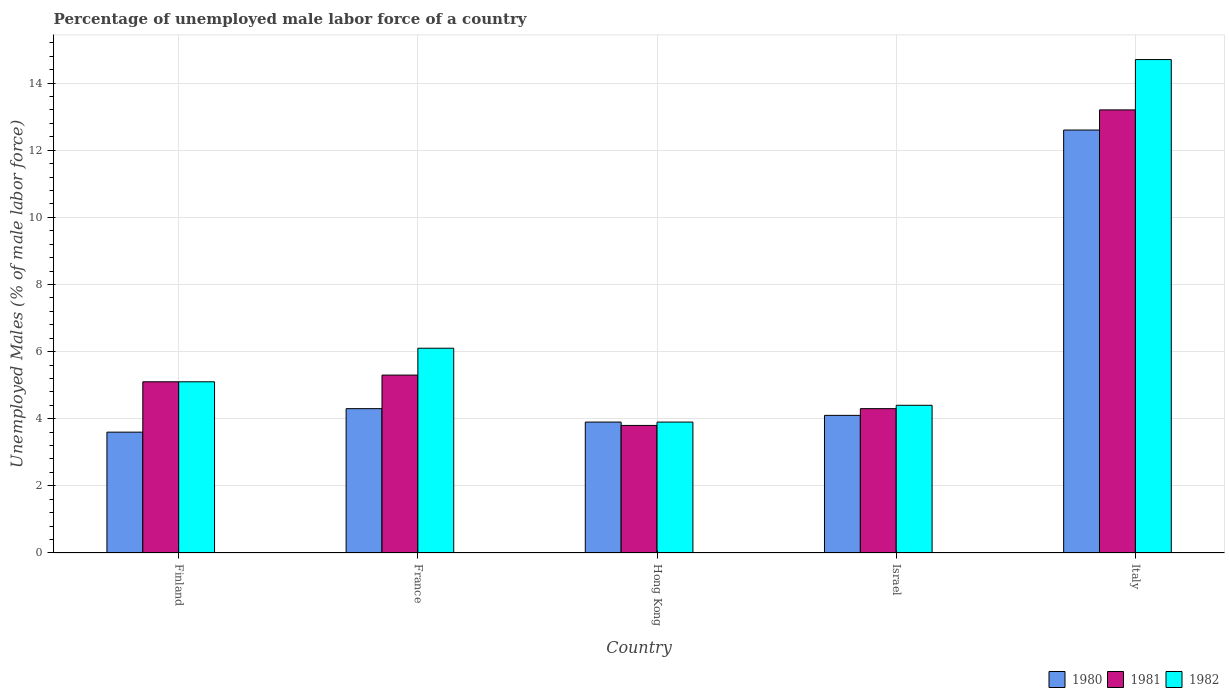How many different coloured bars are there?
Your response must be concise. 3. How many groups of bars are there?
Keep it short and to the point. 5. Are the number of bars per tick equal to the number of legend labels?
Ensure brevity in your answer.  Yes. How many bars are there on the 5th tick from the right?
Provide a succinct answer. 3. What is the percentage of unemployed male labor force in 1980 in Hong Kong?
Give a very brief answer. 3.9. Across all countries, what is the maximum percentage of unemployed male labor force in 1980?
Make the answer very short. 12.6. Across all countries, what is the minimum percentage of unemployed male labor force in 1980?
Make the answer very short. 3.6. In which country was the percentage of unemployed male labor force in 1980 maximum?
Offer a terse response. Italy. In which country was the percentage of unemployed male labor force in 1980 minimum?
Offer a very short reply. Finland. What is the total percentage of unemployed male labor force in 1980 in the graph?
Ensure brevity in your answer.  28.5. What is the difference between the percentage of unemployed male labor force in 1980 in Finland and that in France?
Provide a succinct answer. -0.7. What is the difference between the percentage of unemployed male labor force in 1982 in France and the percentage of unemployed male labor force in 1980 in Israel?
Keep it short and to the point. 2. What is the average percentage of unemployed male labor force in 1981 per country?
Give a very brief answer. 6.34. What is the difference between the percentage of unemployed male labor force of/in 1981 and percentage of unemployed male labor force of/in 1980 in Italy?
Offer a very short reply. 0.6. What is the ratio of the percentage of unemployed male labor force in 1982 in Finland to that in Italy?
Provide a short and direct response. 0.35. What is the difference between the highest and the second highest percentage of unemployed male labor force in 1982?
Your answer should be very brief. -9.6. What is the difference between the highest and the lowest percentage of unemployed male labor force in 1981?
Your answer should be very brief. 9.4. In how many countries, is the percentage of unemployed male labor force in 1982 greater than the average percentage of unemployed male labor force in 1982 taken over all countries?
Offer a very short reply. 1. Is the sum of the percentage of unemployed male labor force in 1981 in Finland and Israel greater than the maximum percentage of unemployed male labor force in 1980 across all countries?
Your answer should be compact. No. What does the 1st bar from the left in Finland represents?
Your answer should be compact. 1980. What does the 1st bar from the right in France represents?
Offer a very short reply. 1982. Are all the bars in the graph horizontal?
Offer a terse response. No. How many countries are there in the graph?
Give a very brief answer. 5. What is the difference between two consecutive major ticks on the Y-axis?
Make the answer very short. 2. Are the values on the major ticks of Y-axis written in scientific E-notation?
Offer a very short reply. No. Where does the legend appear in the graph?
Your answer should be very brief. Bottom right. How are the legend labels stacked?
Keep it short and to the point. Horizontal. What is the title of the graph?
Offer a very short reply. Percentage of unemployed male labor force of a country. What is the label or title of the Y-axis?
Provide a short and direct response. Unemployed Males (% of male labor force). What is the Unemployed Males (% of male labor force) of 1980 in Finland?
Offer a very short reply. 3.6. What is the Unemployed Males (% of male labor force) in 1981 in Finland?
Your answer should be very brief. 5.1. What is the Unemployed Males (% of male labor force) of 1982 in Finland?
Keep it short and to the point. 5.1. What is the Unemployed Males (% of male labor force) in 1980 in France?
Give a very brief answer. 4.3. What is the Unemployed Males (% of male labor force) of 1981 in France?
Offer a terse response. 5.3. What is the Unemployed Males (% of male labor force) in 1982 in France?
Provide a succinct answer. 6.1. What is the Unemployed Males (% of male labor force) in 1980 in Hong Kong?
Make the answer very short. 3.9. What is the Unemployed Males (% of male labor force) of 1981 in Hong Kong?
Keep it short and to the point. 3.8. What is the Unemployed Males (% of male labor force) in 1982 in Hong Kong?
Ensure brevity in your answer.  3.9. What is the Unemployed Males (% of male labor force) of 1980 in Israel?
Your response must be concise. 4.1. What is the Unemployed Males (% of male labor force) in 1981 in Israel?
Your answer should be very brief. 4.3. What is the Unemployed Males (% of male labor force) in 1982 in Israel?
Your answer should be very brief. 4.4. What is the Unemployed Males (% of male labor force) in 1980 in Italy?
Offer a very short reply. 12.6. What is the Unemployed Males (% of male labor force) in 1981 in Italy?
Your answer should be compact. 13.2. What is the Unemployed Males (% of male labor force) of 1982 in Italy?
Ensure brevity in your answer.  14.7. Across all countries, what is the maximum Unemployed Males (% of male labor force) of 1980?
Offer a very short reply. 12.6. Across all countries, what is the maximum Unemployed Males (% of male labor force) of 1981?
Ensure brevity in your answer.  13.2. Across all countries, what is the maximum Unemployed Males (% of male labor force) of 1982?
Your answer should be very brief. 14.7. Across all countries, what is the minimum Unemployed Males (% of male labor force) of 1980?
Keep it short and to the point. 3.6. Across all countries, what is the minimum Unemployed Males (% of male labor force) of 1981?
Provide a short and direct response. 3.8. Across all countries, what is the minimum Unemployed Males (% of male labor force) of 1982?
Your answer should be compact. 3.9. What is the total Unemployed Males (% of male labor force) in 1981 in the graph?
Your answer should be very brief. 31.7. What is the total Unemployed Males (% of male labor force) in 1982 in the graph?
Offer a terse response. 34.2. What is the difference between the Unemployed Males (% of male labor force) in 1981 in Finland and that in France?
Offer a very short reply. -0.2. What is the difference between the Unemployed Males (% of male labor force) of 1980 in Finland and that in Israel?
Your answer should be compact. -0.5. What is the difference between the Unemployed Males (% of male labor force) in 1980 in Finland and that in Italy?
Your answer should be very brief. -9. What is the difference between the Unemployed Males (% of male labor force) of 1981 in Finland and that in Italy?
Your answer should be compact. -8.1. What is the difference between the Unemployed Males (% of male labor force) of 1982 in Finland and that in Italy?
Provide a succinct answer. -9.6. What is the difference between the Unemployed Males (% of male labor force) in 1982 in France and that in Hong Kong?
Your response must be concise. 2.2. What is the difference between the Unemployed Males (% of male labor force) of 1981 in France and that in Italy?
Offer a terse response. -7.9. What is the difference between the Unemployed Males (% of male labor force) in 1980 in Hong Kong and that in Israel?
Keep it short and to the point. -0.2. What is the difference between the Unemployed Males (% of male labor force) of 1981 in Hong Kong and that in Israel?
Your answer should be compact. -0.5. What is the difference between the Unemployed Males (% of male labor force) in 1980 in Hong Kong and that in Italy?
Provide a succinct answer. -8.7. What is the difference between the Unemployed Males (% of male labor force) in 1981 in Hong Kong and that in Italy?
Ensure brevity in your answer.  -9.4. What is the difference between the Unemployed Males (% of male labor force) in 1980 in Israel and that in Italy?
Your response must be concise. -8.5. What is the difference between the Unemployed Males (% of male labor force) of 1981 in Israel and that in Italy?
Ensure brevity in your answer.  -8.9. What is the difference between the Unemployed Males (% of male labor force) in 1980 in Finland and the Unemployed Males (% of male labor force) in 1981 in France?
Your response must be concise. -1.7. What is the difference between the Unemployed Males (% of male labor force) of 1980 in Finland and the Unemployed Males (% of male labor force) of 1982 in France?
Keep it short and to the point. -2.5. What is the difference between the Unemployed Males (% of male labor force) in 1980 in Finland and the Unemployed Males (% of male labor force) in 1981 in Hong Kong?
Your answer should be compact. -0.2. What is the difference between the Unemployed Males (% of male labor force) of 1980 in Finland and the Unemployed Males (% of male labor force) of 1982 in Hong Kong?
Your answer should be compact. -0.3. What is the difference between the Unemployed Males (% of male labor force) in 1980 in Finland and the Unemployed Males (% of male labor force) in 1981 in Italy?
Give a very brief answer. -9.6. What is the difference between the Unemployed Males (% of male labor force) of 1980 in Finland and the Unemployed Males (% of male labor force) of 1982 in Italy?
Your response must be concise. -11.1. What is the difference between the Unemployed Males (% of male labor force) of 1980 in France and the Unemployed Males (% of male labor force) of 1981 in Hong Kong?
Ensure brevity in your answer.  0.5. What is the difference between the Unemployed Males (% of male labor force) in 1980 in France and the Unemployed Males (% of male labor force) in 1982 in Hong Kong?
Keep it short and to the point. 0.4. What is the difference between the Unemployed Males (% of male labor force) of 1980 in France and the Unemployed Males (% of male labor force) of 1981 in Israel?
Provide a succinct answer. 0. What is the difference between the Unemployed Males (% of male labor force) in 1980 in France and the Unemployed Males (% of male labor force) in 1981 in Italy?
Make the answer very short. -8.9. What is the difference between the Unemployed Males (% of male labor force) of 1980 in France and the Unemployed Males (% of male labor force) of 1982 in Italy?
Ensure brevity in your answer.  -10.4. What is the difference between the Unemployed Males (% of male labor force) of 1981 in France and the Unemployed Males (% of male labor force) of 1982 in Italy?
Your answer should be compact. -9.4. What is the difference between the Unemployed Males (% of male labor force) in 1980 in Hong Kong and the Unemployed Males (% of male labor force) in 1981 in Israel?
Provide a short and direct response. -0.4. What is the difference between the Unemployed Males (% of male labor force) of 1980 in Hong Kong and the Unemployed Males (% of male labor force) of 1982 in Israel?
Your answer should be compact. -0.5. What is the difference between the Unemployed Males (% of male labor force) of 1980 in Hong Kong and the Unemployed Males (% of male labor force) of 1981 in Italy?
Provide a succinct answer. -9.3. What is the difference between the Unemployed Males (% of male labor force) of 1980 in Israel and the Unemployed Males (% of male labor force) of 1982 in Italy?
Give a very brief answer. -10.6. What is the difference between the Unemployed Males (% of male labor force) of 1981 in Israel and the Unemployed Males (% of male labor force) of 1982 in Italy?
Your response must be concise. -10.4. What is the average Unemployed Males (% of male labor force) of 1981 per country?
Provide a succinct answer. 6.34. What is the average Unemployed Males (% of male labor force) in 1982 per country?
Provide a succinct answer. 6.84. What is the difference between the Unemployed Males (% of male labor force) of 1980 and Unemployed Males (% of male labor force) of 1982 in Finland?
Your response must be concise. -1.5. What is the difference between the Unemployed Males (% of male labor force) in 1981 and Unemployed Males (% of male labor force) in 1982 in Finland?
Ensure brevity in your answer.  0. What is the difference between the Unemployed Males (% of male labor force) in 1980 and Unemployed Males (% of male labor force) in 1981 in France?
Provide a short and direct response. -1. What is the difference between the Unemployed Males (% of male labor force) in 1981 and Unemployed Males (% of male labor force) in 1982 in France?
Provide a succinct answer. -0.8. What is the difference between the Unemployed Males (% of male labor force) in 1980 and Unemployed Males (% of male labor force) in 1982 in Hong Kong?
Your response must be concise. 0. What is the difference between the Unemployed Males (% of male labor force) of 1981 and Unemployed Males (% of male labor force) of 1982 in Hong Kong?
Provide a short and direct response. -0.1. What is the difference between the Unemployed Males (% of male labor force) in 1981 and Unemployed Males (% of male labor force) in 1982 in Israel?
Provide a succinct answer. -0.1. What is the ratio of the Unemployed Males (% of male labor force) in 1980 in Finland to that in France?
Offer a terse response. 0.84. What is the ratio of the Unemployed Males (% of male labor force) in 1981 in Finland to that in France?
Your answer should be compact. 0.96. What is the ratio of the Unemployed Males (% of male labor force) of 1982 in Finland to that in France?
Offer a terse response. 0.84. What is the ratio of the Unemployed Males (% of male labor force) of 1981 in Finland to that in Hong Kong?
Your response must be concise. 1.34. What is the ratio of the Unemployed Males (% of male labor force) of 1982 in Finland to that in Hong Kong?
Your response must be concise. 1.31. What is the ratio of the Unemployed Males (% of male labor force) in 1980 in Finland to that in Israel?
Your answer should be compact. 0.88. What is the ratio of the Unemployed Males (% of male labor force) in 1981 in Finland to that in Israel?
Offer a terse response. 1.19. What is the ratio of the Unemployed Males (% of male labor force) in 1982 in Finland to that in Israel?
Keep it short and to the point. 1.16. What is the ratio of the Unemployed Males (% of male labor force) in 1980 in Finland to that in Italy?
Make the answer very short. 0.29. What is the ratio of the Unemployed Males (% of male labor force) of 1981 in Finland to that in Italy?
Give a very brief answer. 0.39. What is the ratio of the Unemployed Males (% of male labor force) of 1982 in Finland to that in Italy?
Provide a succinct answer. 0.35. What is the ratio of the Unemployed Males (% of male labor force) of 1980 in France to that in Hong Kong?
Keep it short and to the point. 1.1. What is the ratio of the Unemployed Males (% of male labor force) in 1981 in France to that in Hong Kong?
Your answer should be compact. 1.39. What is the ratio of the Unemployed Males (% of male labor force) in 1982 in France to that in Hong Kong?
Offer a very short reply. 1.56. What is the ratio of the Unemployed Males (% of male labor force) of 1980 in France to that in Israel?
Make the answer very short. 1.05. What is the ratio of the Unemployed Males (% of male labor force) in 1981 in France to that in Israel?
Offer a terse response. 1.23. What is the ratio of the Unemployed Males (% of male labor force) of 1982 in France to that in Israel?
Ensure brevity in your answer.  1.39. What is the ratio of the Unemployed Males (% of male labor force) of 1980 in France to that in Italy?
Ensure brevity in your answer.  0.34. What is the ratio of the Unemployed Males (% of male labor force) in 1981 in France to that in Italy?
Your response must be concise. 0.4. What is the ratio of the Unemployed Males (% of male labor force) of 1982 in France to that in Italy?
Your answer should be compact. 0.41. What is the ratio of the Unemployed Males (% of male labor force) of 1980 in Hong Kong to that in Israel?
Offer a very short reply. 0.95. What is the ratio of the Unemployed Males (% of male labor force) of 1981 in Hong Kong to that in Israel?
Ensure brevity in your answer.  0.88. What is the ratio of the Unemployed Males (% of male labor force) in 1982 in Hong Kong to that in Israel?
Give a very brief answer. 0.89. What is the ratio of the Unemployed Males (% of male labor force) of 1980 in Hong Kong to that in Italy?
Your answer should be compact. 0.31. What is the ratio of the Unemployed Males (% of male labor force) in 1981 in Hong Kong to that in Italy?
Provide a short and direct response. 0.29. What is the ratio of the Unemployed Males (% of male labor force) in 1982 in Hong Kong to that in Italy?
Your response must be concise. 0.27. What is the ratio of the Unemployed Males (% of male labor force) in 1980 in Israel to that in Italy?
Ensure brevity in your answer.  0.33. What is the ratio of the Unemployed Males (% of male labor force) of 1981 in Israel to that in Italy?
Give a very brief answer. 0.33. What is the ratio of the Unemployed Males (% of male labor force) of 1982 in Israel to that in Italy?
Offer a very short reply. 0.3. What is the difference between the highest and the lowest Unemployed Males (% of male labor force) of 1980?
Your answer should be very brief. 9. What is the difference between the highest and the lowest Unemployed Males (% of male labor force) of 1981?
Ensure brevity in your answer.  9.4. 